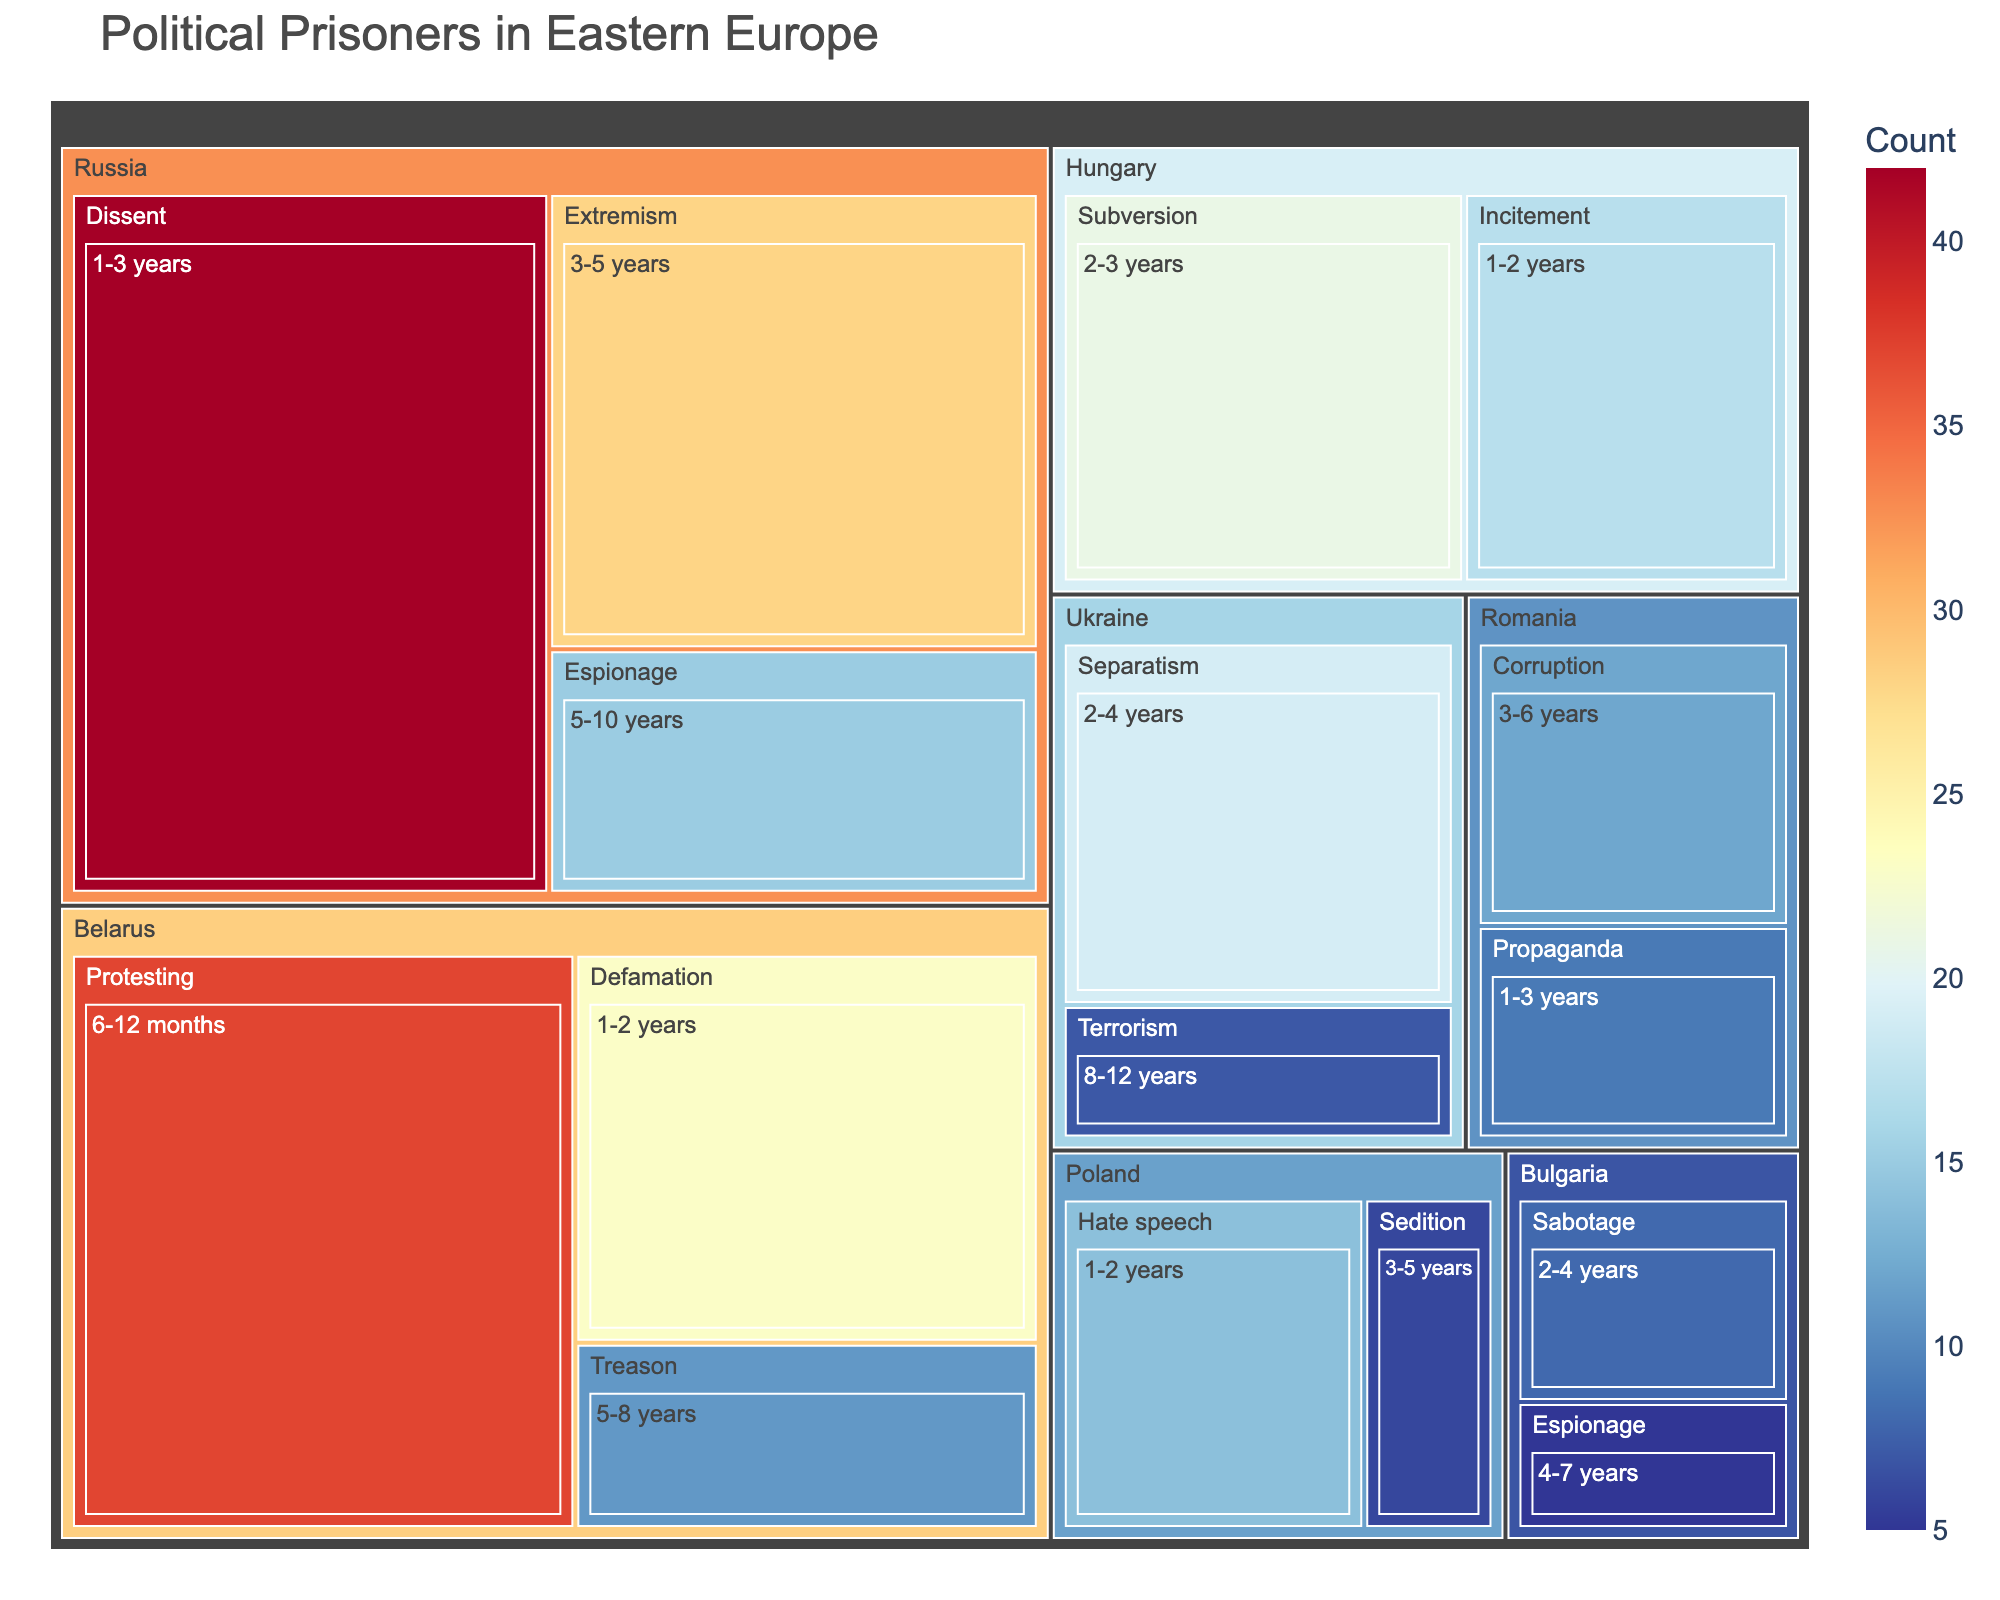Which country has the highest number of political prisoners? Referring to the treemap, we can see that Russia has the largest portion with multiple categories and durations, indicating it has the highest number of political prisoners.
Answer: Russia What is the most common charge for political prisoners in Russia? The treemap shows multiple charges within Russia, with "Dissent" having the highest count, indicating it is the most common charge.
Answer: Dissent How many political prisoners in Ukraine are charged with Terrorism? By observing the treemap section for Ukraine and looking at the "Terrorism" category, we see a count of 7.
Answer: 7 Which charge in Belarus has durations of 5-8 years? Checking the Belarus section, we see the charge “Treason” associated with the 5-8 years duration.
Answer: Treason Compare the number of political prisoners charged with Espionage in Russia and Bulgaria. Which country has more? Looking at the treemap, Russia has 15 political prisoners charged with Espionage, while Bulgaria has 5. Thus, Russia has more.
Answer: Russia What is the shortest detention duration among the political prisoners in Belarus? In the treemap, the charge with the shortest duration in Belarus is "Protesting," which has a duration of 6-12 months.
Answer: 6-12 months What is the total number of political prisoners in Hungary? Summing the counts for Hungary: Subversion (21) + Incitement (17) gives a total of 38 political prisoners.
Answer: 38 Which country has the fewest political prisoners according to the treemap? Referring to various countries, Bulgaria has the fewest political prisoners with counts of 5 (Espionage) and 8 (Sabotage), totaling 13.
Answer: Bulgaria Between the charges of Sedition in Poland and Separatism in Ukraine, which has more political prisoners? The treemap shows that Poland has 6 for Sedition and Ukraine has 19 for Separatism. Therefore, Separatism in Ukraine has more.
Answer: Separatism in Ukraine What’s the average detention duration range for charges in Romania? Looking at Romania, we see durations of 3-6 years (Corruption) and 1-3 years (Propaganda). Averaging the ranges: (3+6)/2 = 4.5 years and (1+3)/2 = 2 years, thus (4.5 + 2)/2 = 3.25 years.
Answer: 3.25 years 